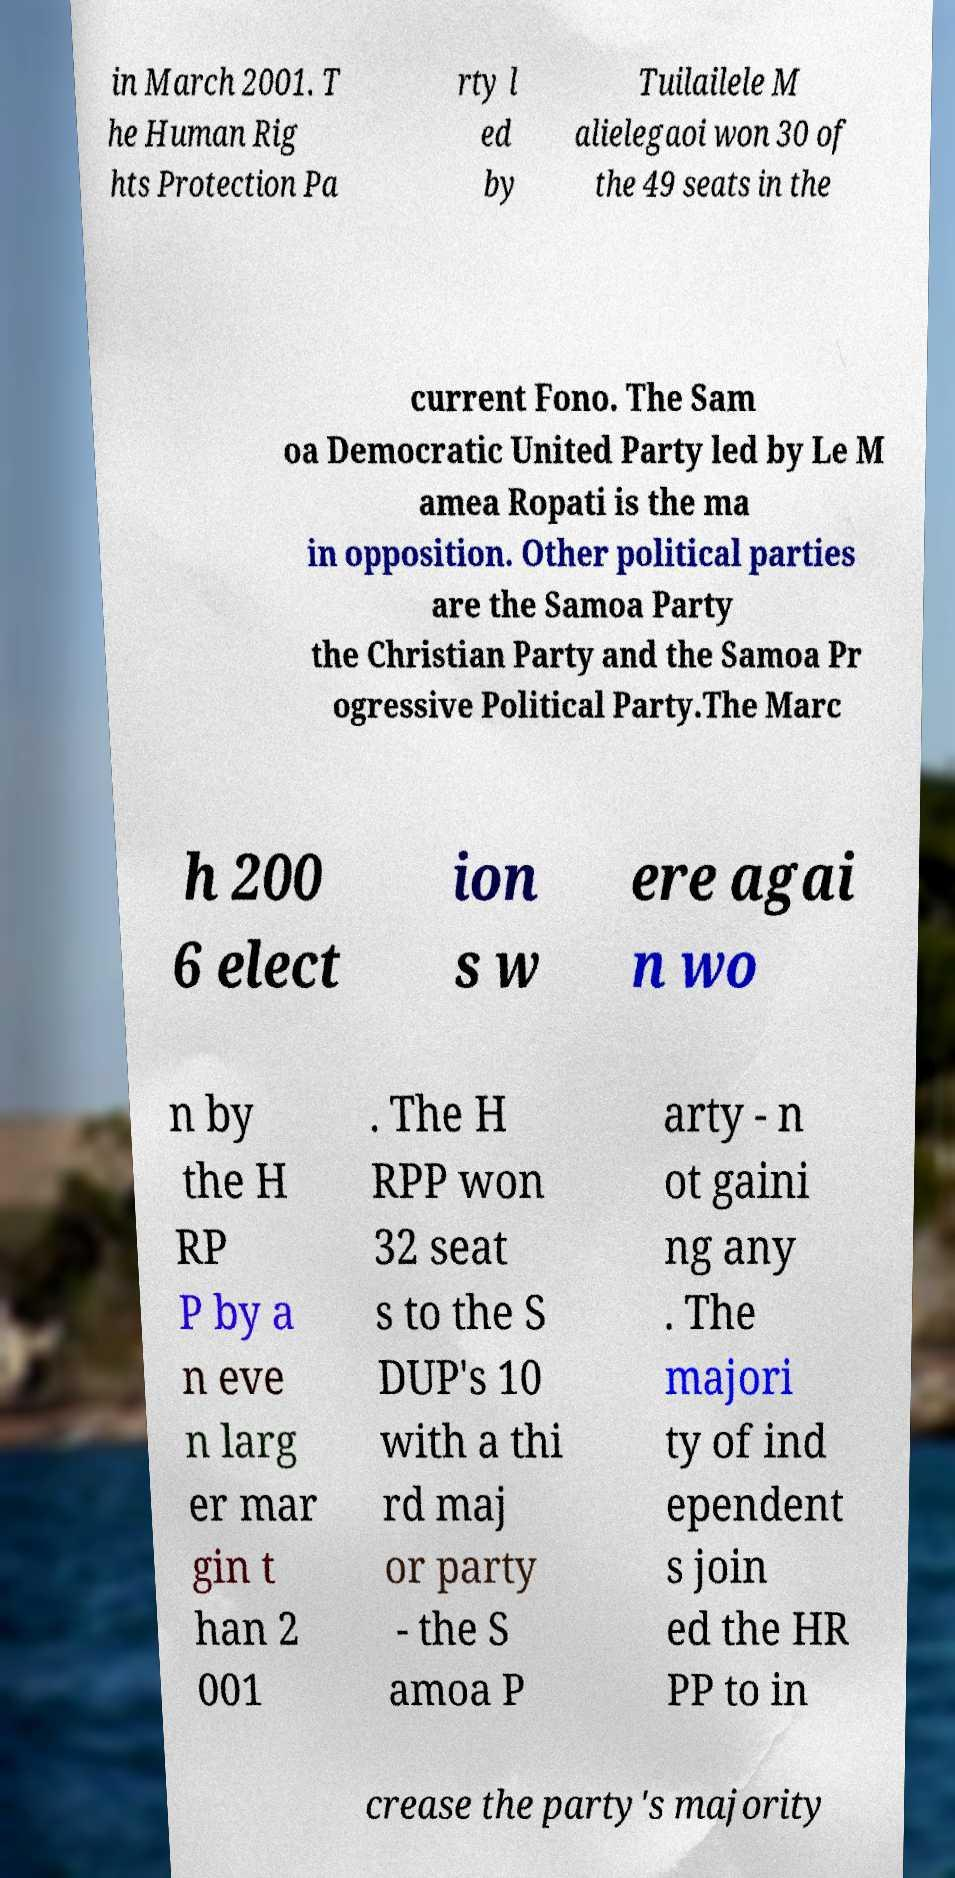Could you extract and type out the text from this image? in March 2001. T he Human Rig hts Protection Pa rty l ed by Tuilailele M alielegaoi won 30 of the 49 seats in the current Fono. The Sam oa Democratic United Party led by Le M amea Ropati is the ma in opposition. Other political parties are the Samoa Party the Christian Party and the Samoa Pr ogressive Political Party.The Marc h 200 6 elect ion s w ere agai n wo n by the H RP P by a n eve n larg er mar gin t han 2 001 . The H RPP won 32 seat s to the S DUP's 10 with a thi rd maj or party - the S amoa P arty - n ot gaini ng any . The majori ty of ind ependent s join ed the HR PP to in crease the party's majority 